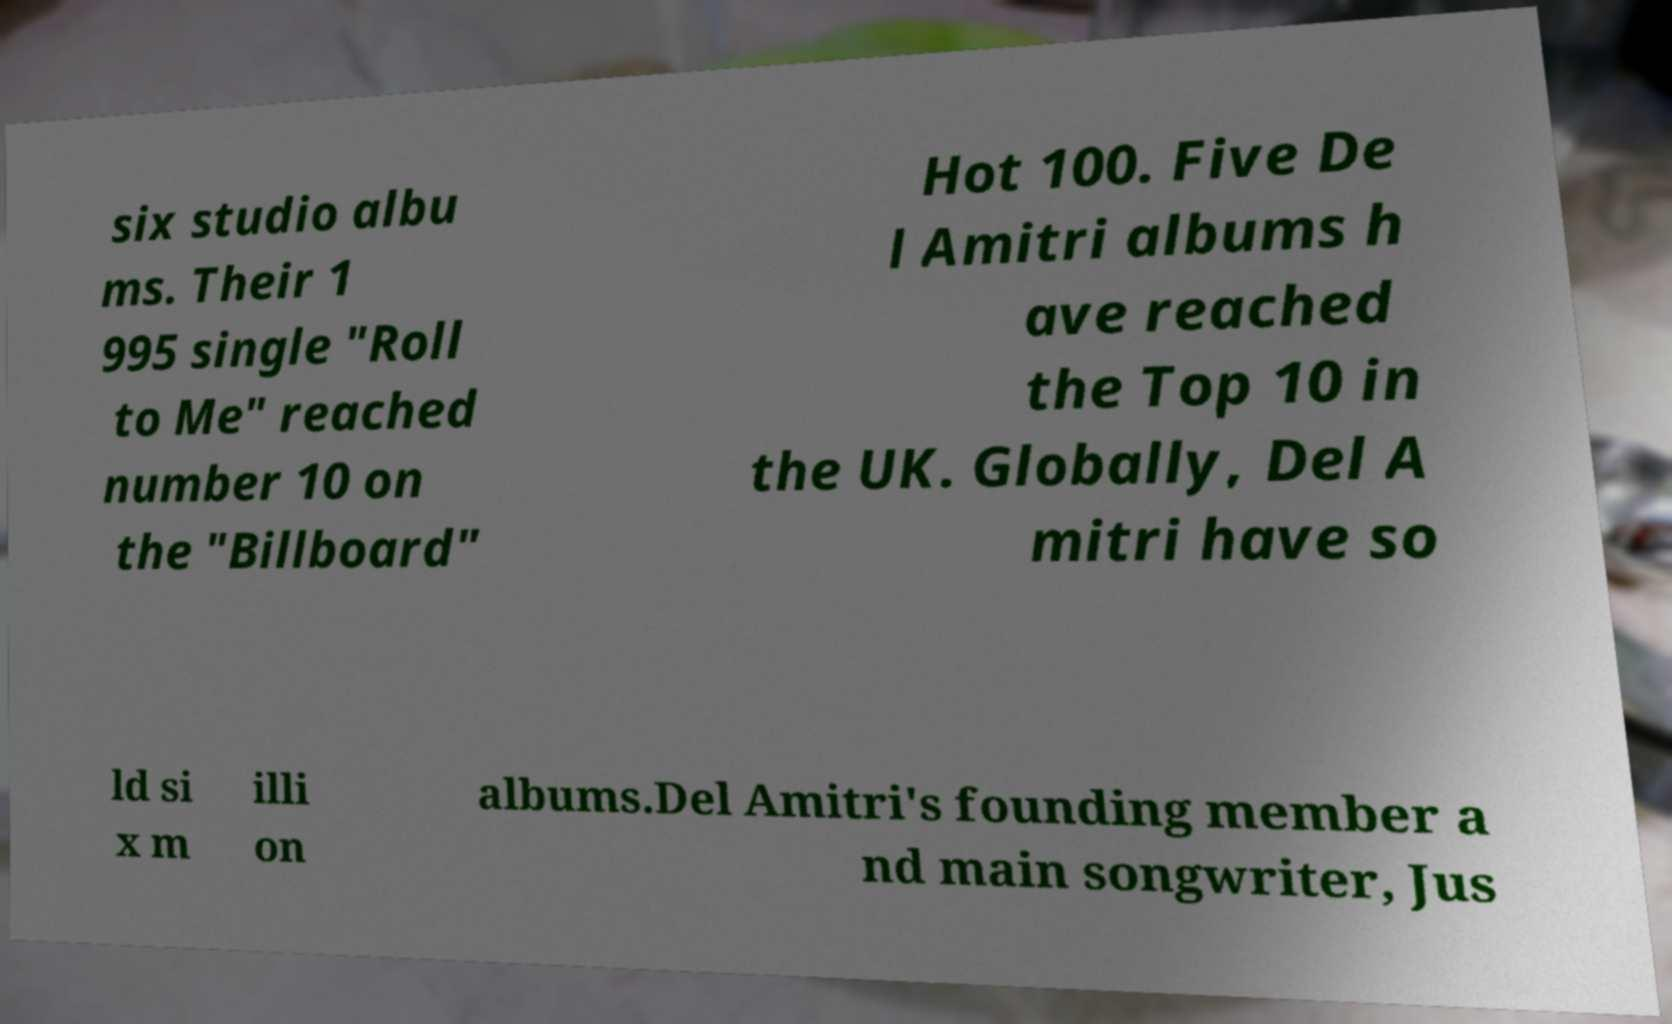I need the written content from this picture converted into text. Can you do that? six studio albu ms. Their 1 995 single "Roll to Me" reached number 10 on the "Billboard" Hot 100. Five De l Amitri albums h ave reached the Top 10 in the UK. Globally, Del A mitri have so ld si x m illi on albums.Del Amitri's founding member a nd main songwriter, Jus 